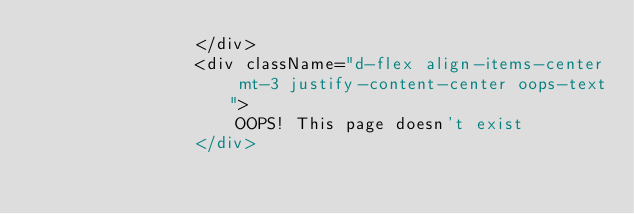Convert code to text. <code><loc_0><loc_0><loc_500><loc_500><_JavaScript_>                </div>
                <div className="d-flex align-items-center mt-3 justify-content-center oops-text">
                    OOPS! This page doesn't exist
                </div></code> 